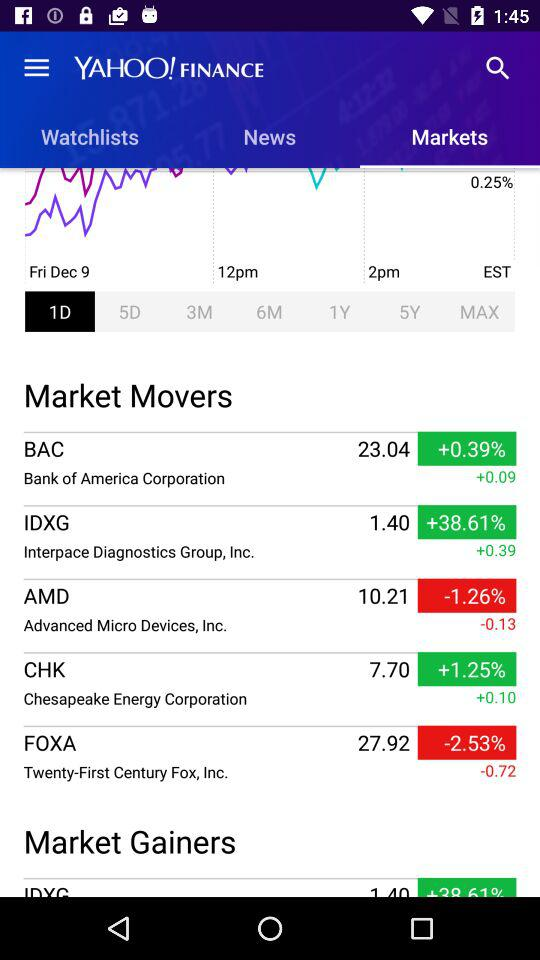What is the increment in "Chesapeake Energy Corporation"? The increment is +0.10. 